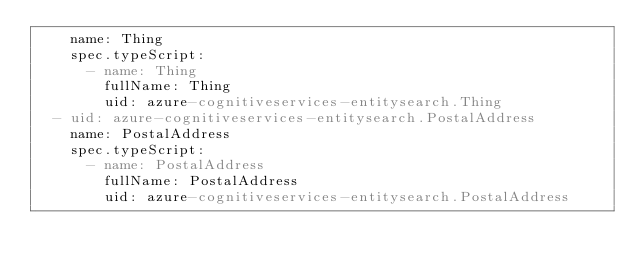<code> <loc_0><loc_0><loc_500><loc_500><_YAML_>    name: Thing
    spec.typeScript:
      - name: Thing
        fullName: Thing
        uid: azure-cognitiveservices-entitysearch.Thing
  - uid: azure-cognitiveservices-entitysearch.PostalAddress
    name: PostalAddress
    spec.typeScript:
      - name: PostalAddress
        fullName: PostalAddress
        uid: azure-cognitiveservices-entitysearch.PostalAddress
</code> 